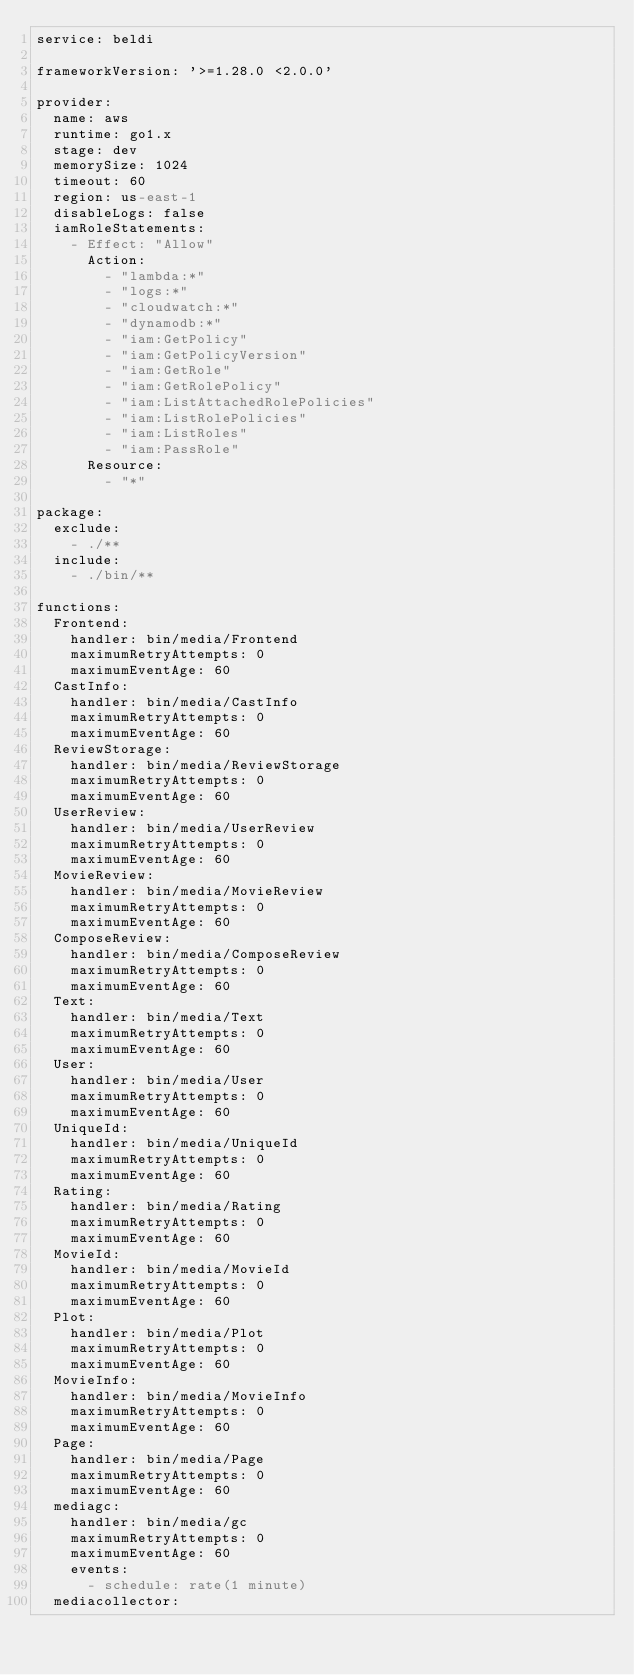<code> <loc_0><loc_0><loc_500><loc_500><_YAML_>service: beldi

frameworkVersion: '>=1.28.0 <2.0.0'

provider:
  name: aws
  runtime: go1.x
  stage: dev
  memorySize: 1024
  timeout: 60
  region: us-east-1
  disableLogs: false
  iamRoleStatements:
    - Effect: "Allow"
      Action:
        - "lambda:*"
        - "logs:*"
        - "cloudwatch:*"
        - "dynamodb:*"
        - "iam:GetPolicy"
        - "iam:GetPolicyVersion"
        - "iam:GetRole"
        - "iam:GetRolePolicy"
        - "iam:ListAttachedRolePolicies"
        - "iam:ListRolePolicies"
        - "iam:ListRoles"
        - "iam:PassRole"
      Resource:
        - "*"

package:
  exclude:
    - ./**
  include:
    - ./bin/**

functions:
  Frontend:
    handler: bin/media/Frontend
    maximumRetryAttempts: 0
    maximumEventAge: 60
  CastInfo:
    handler: bin/media/CastInfo
    maximumRetryAttempts: 0
    maximumEventAge: 60
  ReviewStorage:
    handler: bin/media/ReviewStorage
    maximumRetryAttempts: 0
    maximumEventAge: 60
  UserReview:
    handler: bin/media/UserReview
    maximumRetryAttempts: 0
    maximumEventAge: 60
  MovieReview:
    handler: bin/media/MovieReview
    maximumRetryAttempts: 0
    maximumEventAge: 60
  ComposeReview:
    handler: bin/media/ComposeReview
    maximumRetryAttempts: 0
    maximumEventAge: 60
  Text:
    handler: bin/media/Text
    maximumRetryAttempts: 0
    maximumEventAge: 60
  User:
    handler: bin/media/User
    maximumRetryAttempts: 0
    maximumEventAge: 60
  UniqueId:
    handler: bin/media/UniqueId
    maximumRetryAttempts: 0
    maximumEventAge: 60
  Rating:
    handler: bin/media/Rating
    maximumRetryAttempts: 0
    maximumEventAge: 60
  MovieId:
    handler: bin/media/MovieId
    maximumRetryAttempts: 0
    maximumEventAge: 60
  Plot:
    handler: bin/media/Plot
    maximumRetryAttempts: 0
    maximumEventAge: 60
  MovieInfo:
    handler: bin/media/MovieInfo
    maximumRetryAttempts: 0
    maximumEventAge: 60
  Page:
    handler: bin/media/Page
    maximumRetryAttempts: 0
    maximumEventAge: 60
  mediagc:
    handler: bin/media/gc
    maximumRetryAttempts: 0
    maximumEventAge: 60
    events:
      - schedule: rate(1 minute)
  mediacollector:</code> 